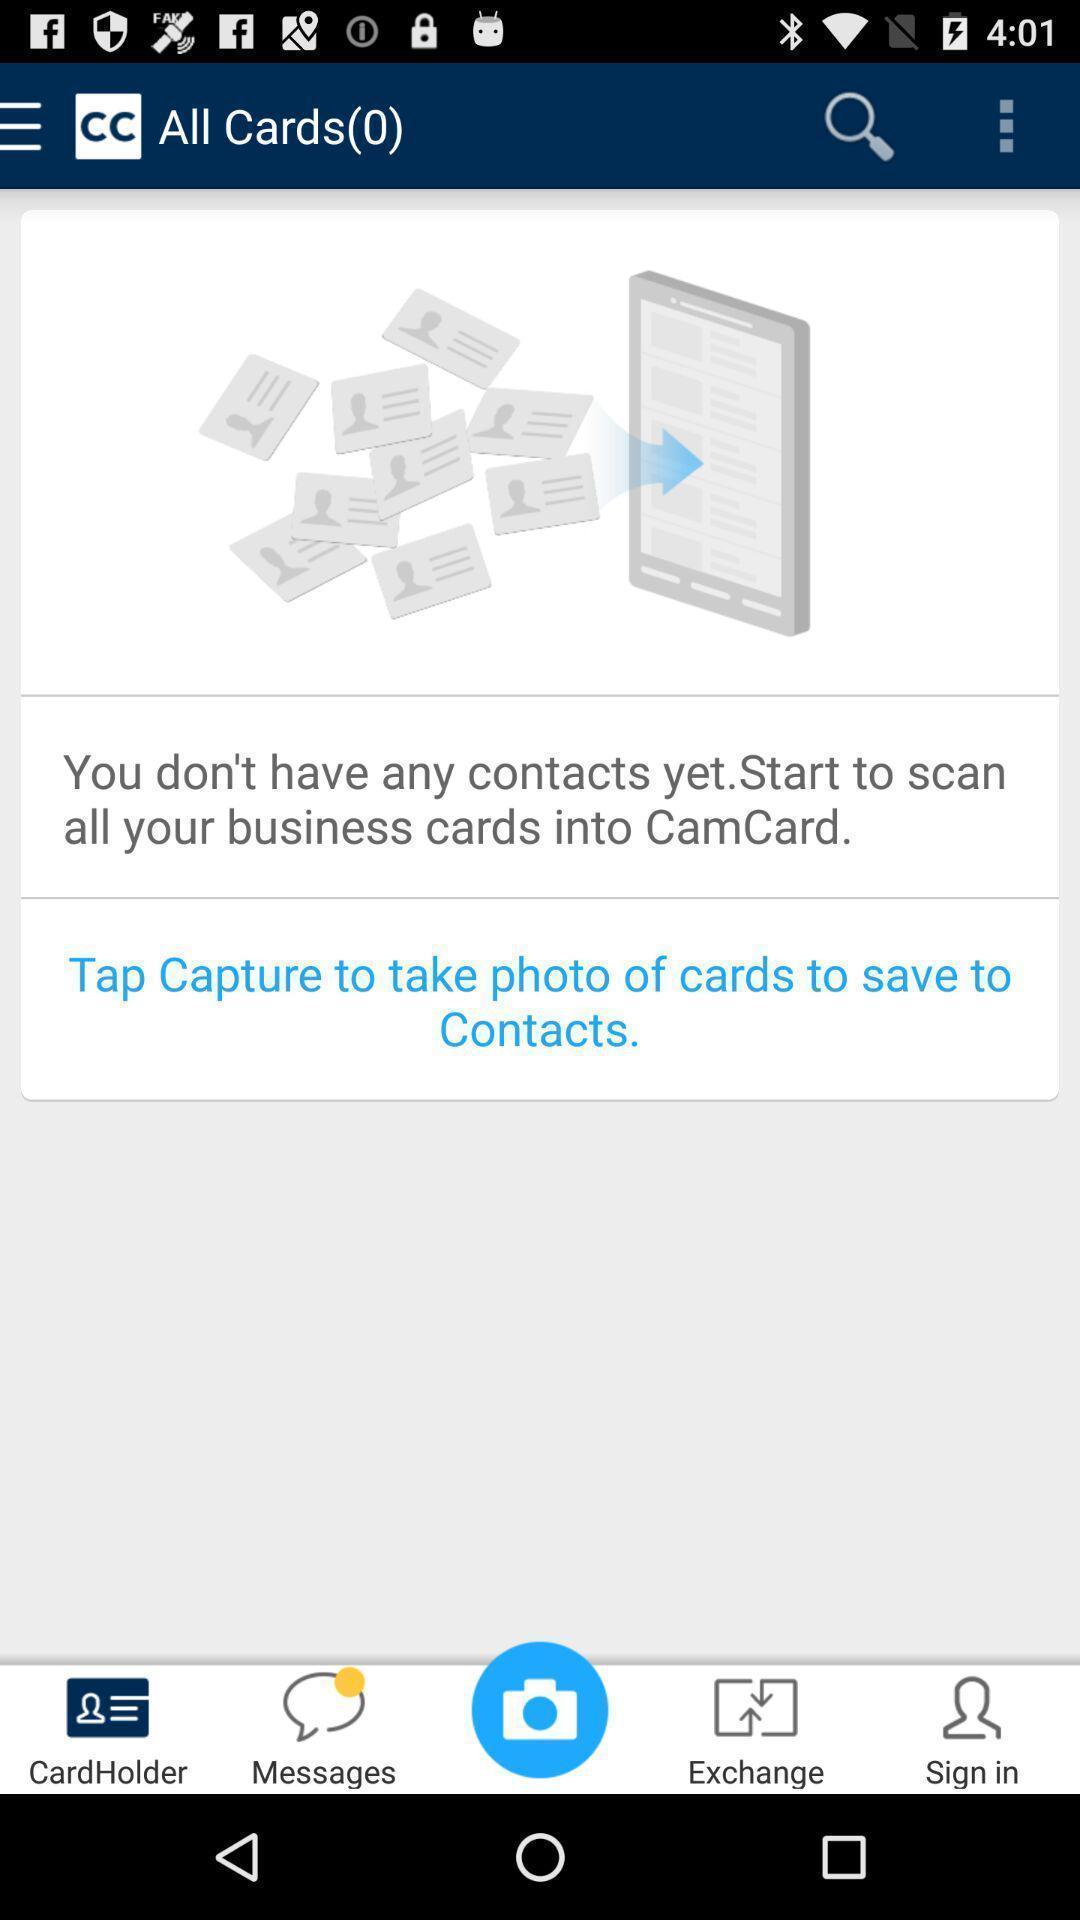Explain what's happening in this screen capture. Pop-up showing the home page. 